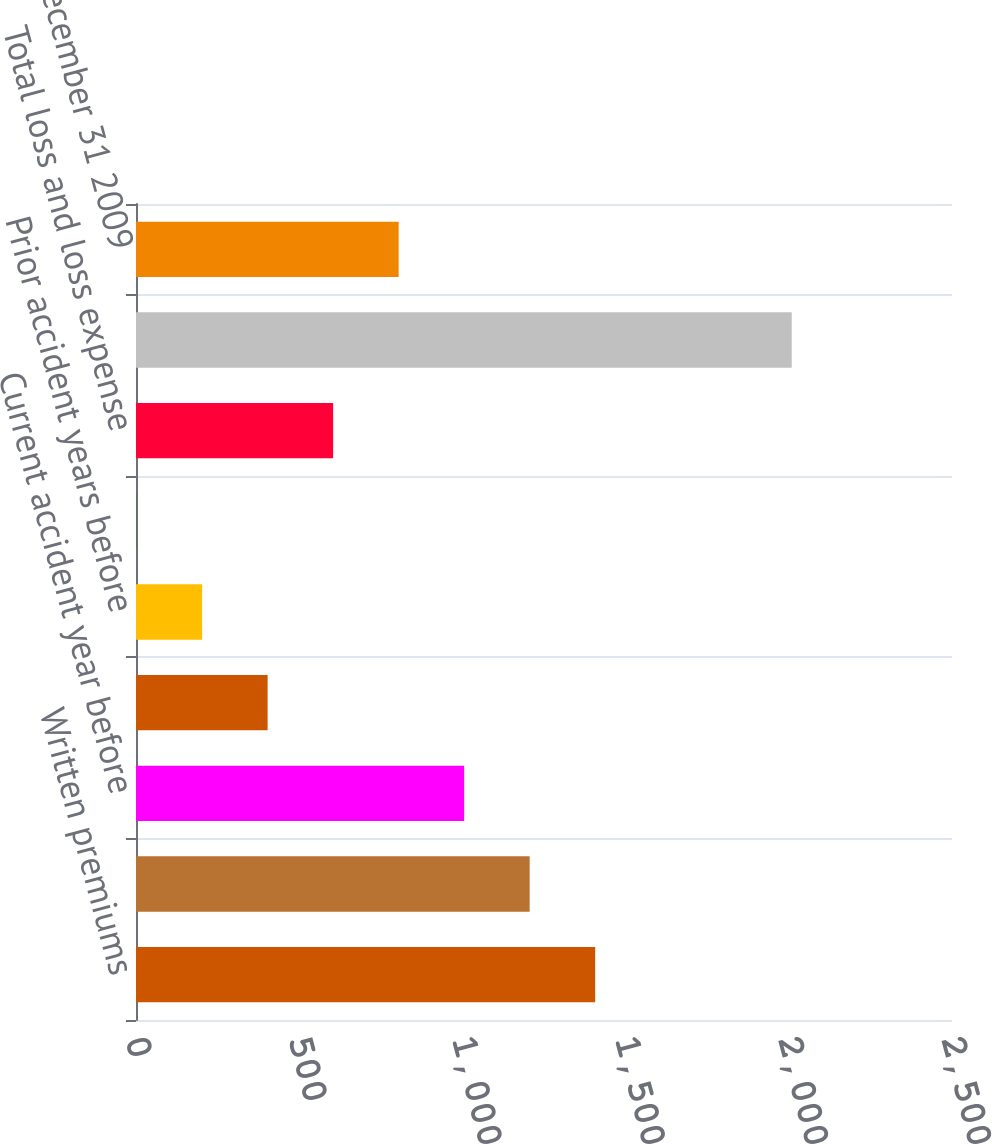Convert chart. <chart><loc_0><loc_0><loc_500><loc_500><bar_chart><fcel>Written premiums<fcel>Earned premiums<fcel>Current accident year before<fcel>Current accident year<fcel>Prior accident years before<fcel>Prior accident year<fcel>Total loss and loss expense<fcel>Accident Year<fcel>as of December 31 2009<nl><fcel>1406.84<fcel>1206.12<fcel>1005.4<fcel>403.24<fcel>202.52<fcel>1.8<fcel>603.96<fcel>2009<fcel>804.68<nl></chart> 